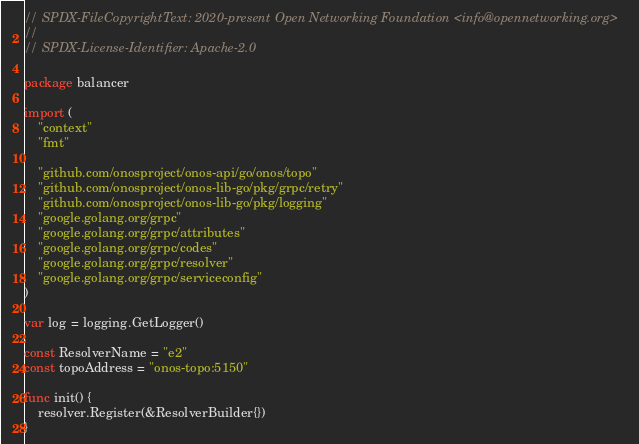<code> <loc_0><loc_0><loc_500><loc_500><_Go_>// SPDX-FileCopyrightText: 2020-present Open Networking Foundation <info@opennetworking.org>
//
// SPDX-License-Identifier: Apache-2.0

package balancer

import (
	"context"
	"fmt"

	"github.com/onosproject/onos-api/go/onos/topo"
	"github.com/onosproject/onos-lib-go/pkg/grpc/retry"
	"github.com/onosproject/onos-lib-go/pkg/logging"
	"google.golang.org/grpc"
	"google.golang.org/grpc/attributes"
	"google.golang.org/grpc/codes"
	"google.golang.org/grpc/resolver"
	"google.golang.org/grpc/serviceconfig"
)

var log = logging.GetLogger()

const ResolverName = "e2"
const topoAddress = "onos-topo:5150"

func init() {
	resolver.Register(&ResolverBuilder{})
}
</code> 